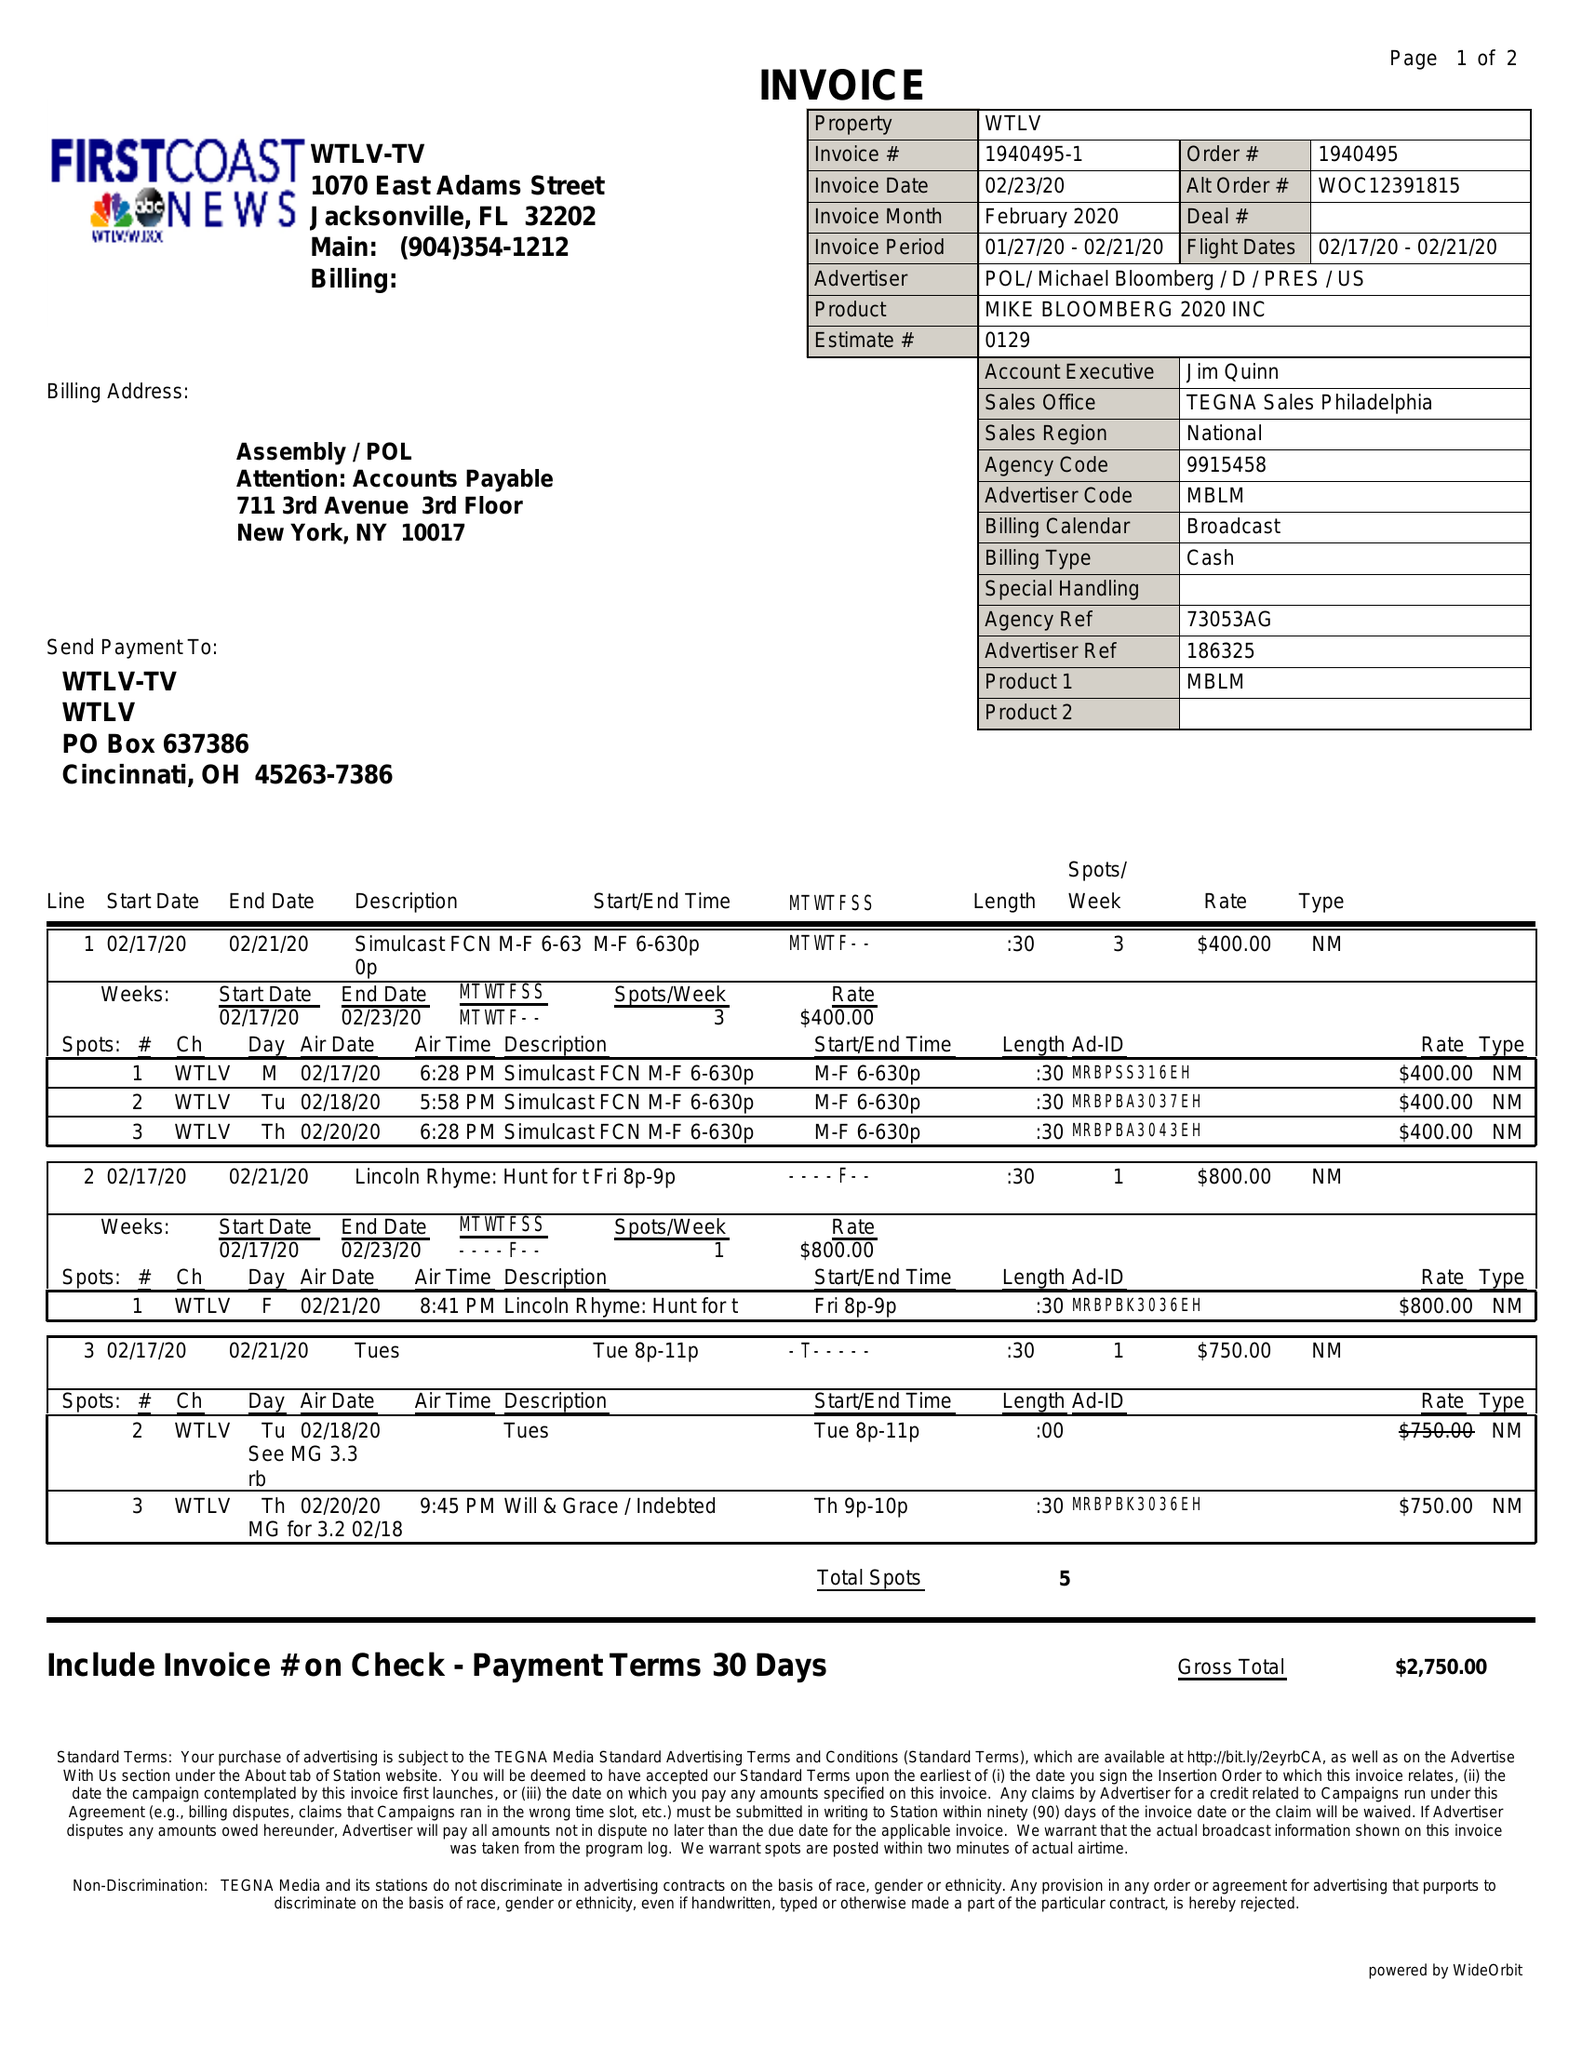What is the value for the advertiser?
Answer the question using a single word or phrase. POL/MICHAELBLOOMBERG/D/PRES/US 